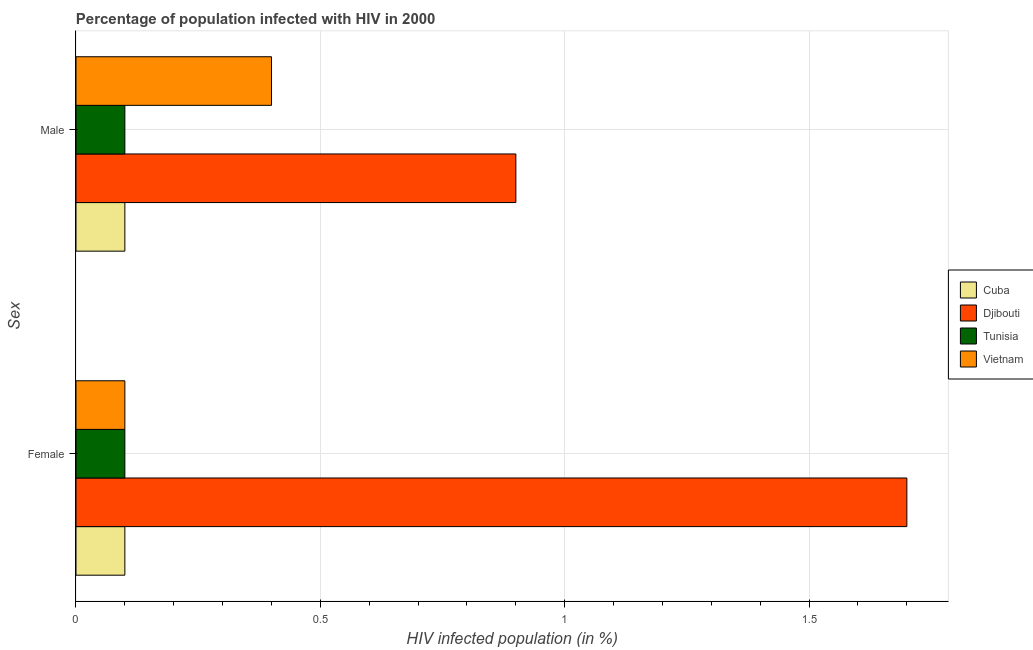How many groups of bars are there?
Your response must be concise. 2. How many bars are there on the 1st tick from the top?
Give a very brief answer. 4. What is the label of the 1st group of bars from the top?
Your answer should be very brief. Male. What is the percentage of males who are infected with hiv in Vietnam?
Ensure brevity in your answer.  0.4. In which country was the percentage of females who are infected with hiv maximum?
Give a very brief answer. Djibouti. In which country was the percentage of males who are infected with hiv minimum?
Keep it short and to the point. Cuba. What is the total percentage of females who are infected with hiv in the graph?
Provide a succinct answer. 2. What is the difference between the percentage of females who are infected with hiv in Cuba and that in Djibouti?
Give a very brief answer. -1.6. What is the difference between the percentage of males who are infected with hiv in Cuba and the percentage of females who are infected with hiv in Djibouti?
Your answer should be compact. -1.6. What is the difference between the percentage of females who are infected with hiv and percentage of males who are infected with hiv in Cuba?
Offer a terse response. 0. What is the ratio of the percentage of females who are infected with hiv in Tunisia to that in Vietnam?
Offer a very short reply. 1. Is the percentage of females who are infected with hiv in Tunisia less than that in Cuba?
Ensure brevity in your answer.  No. What does the 2nd bar from the top in Male represents?
Ensure brevity in your answer.  Tunisia. What does the 2nd bar from the bottom in Female represents?
Give a very brief answer. Djibouti. Are all the bars in the graph horizontal?
Your response must be concise. Yes. How many countries are there in the graph?
Ensure brevity in your answer.  4. Does the graph contain grids?
Your answer should be compact. Yes. What is the title of the graph?
Give a very brief answer. Percentage of population infected with HIV in 2000. What is the label or title of the X-axis?
Ensure brevity in your answer.  HIV infected population (in %). What is the label or title of the Y-axis?
Your response must be concise. Sex. What is the HIV infected population (in %) in Cuba in Female?
Provide a succinct answer. 0.1. What is the HIV infected population (in %) in Vietnam in Female?
Offer a terse response. 0.1. What is the HIV infected population (in %) in Cuba in Male?
Keep it short and to the point. 0.1. What is the HIV infected population (in %) in Djibouti in Male?
Your answer should be very brief. 0.9. What is the HIV infected population (in %) of Tunisia in Male?
Offer a very short reply. 0.1. Across all Sex, what is the maximum HIV infected population (in %) in Cuba?
Offer a terse response. 0.1. Across all Sex, what is the maximum HIV infected population (in %) of Djibouti?
Offer a very short reply. 1.7. Across all Sex, what is the maximum HIV infected population (in %) in Vietnam?
Your response must be concise. 0.4. Across all Sex, what is the minimum HIV infected population (in %) of Cuba?
Ensure brevity in your answer.  0.1. Across all Sex, what is the minimum HIV infected population (in %) of Djibouti?
Give a very brief answer. 0.9. Across all Sex, what is the minimum HIV infected population (in %) in Tunisia?
Provide a succinct answer. 0.1. Across all Sex, what is the minimum HIV infected population (in %) of Vietnam?
Provide a short and direct response. 0.1. What is the difference between the HIV infected population (in %) of Cuba in Female and that in Male?
Offer a very short reply. 0. What is the difference between the HIV infected population (in %) of Cuba in Female and the HIV infected population (in %) of Djibouti in Male?
Your response must be concise. -0.8. What is the difference between the HIV infected population (in %) in Cuba in Female and the HIV infected population (in %) in Vietnam in Male?
Offer a terse response. -0.3. What is the difference between the HIV infected population (in %) in Djibouti in Female and the HIV infected population (in %) in Vietnam in Male?
Give a very brief answer. 1.3. What is the average HIV infected population (in %) of Djibouti per Sex?
Make the answer very short. 1.3. What is the average HIV infected population (in %) of Tunisia per Sex?
Ensure brevity in your answer.  0.1. What is the difference between the HIV infected population (in %) in Cuba and HIV infected population (in %) in Tunisia in Female?
Offer a terse response. 0. What is the difference between the HIV infected population (in %) of Cuba and HIV infected population (in %) of Vietnam in Female?
Your answer should be compact. 0. What is the difference between the HIV infected population (in %) of Cuba and HIV infected population (in %) of Djibouti in Male?
Provide a succinct answer. -0.8. What is the difference between the HIV infected population (in %) of Cuba and HIV infected population (in %) of Tunisia in Male?
Provide a short and direct response. 0. What is the difference between the HIV infected population (in %) of Cuba and HIV infected population (in %) of Vietnam in Male?
Offer a very short reply. -0.3. What is the difference between the HIV infected population (in %) of Djibouti and HIV infected population (in %) of Tunisia in Male?
Offer a very short reply. 0.8. What is the difference between the HIV infected population (in %) in Djibouti and HIV infected population (in %) in Vietnam in Male?
Your answer should be very brief. 0.5. What is the ratio of the HIV infected population (in %) in Cuba in Female to that in Male?
Offer a very short reply. 1. What is the ratio of the HIV infected population (in %) of Djibouti in Female to that in Male?
Ensure brevity in your answer.  1.89. What is the ratio of the HIV infected population (in %) in Tunisia in Female to that in Male?
Give a very brief answer. 1. What is the difference between the highest and the second highest HIV infected population (in %) of Djibouti?
Give a very brief answer. 0.8. What is the difference between the highest and the second highest HIV infected population (in %) of Tunisia?
Ensure brevity in your answer.  0. What is the difference between the highest and the second highest HIV infected population (in %) of Vietnam?
Provide a short and direct response. 0.3. What is the difference between the highest and the lowest HIV infected population (in %) of Cuba?
Offer a very short reply. 0. What is the difference between the highest and the lowest HIV infected population (in %) in Djibouti?
Provide a short and direct response. 0.8. 